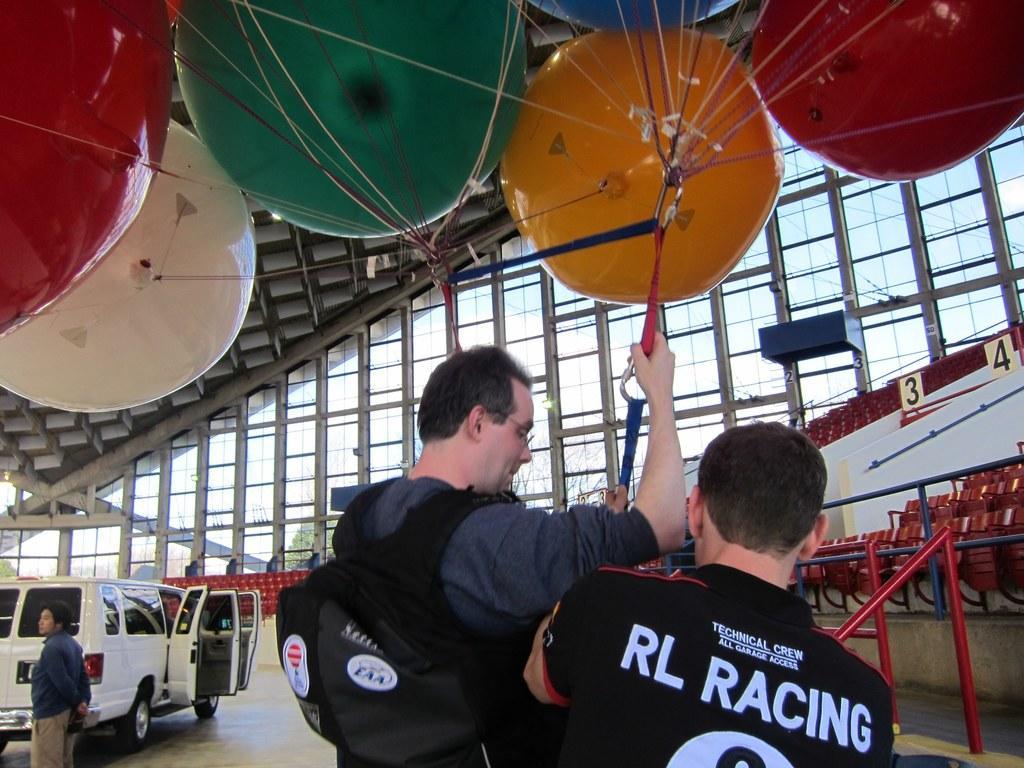In one or two sentences, can you explain what this image depicts? In the foreground of the picture there are two men. At the top there are balloons. On the left there is a van and a person standing. On the right there are chairs and railing. In the background there are glass windows and chairs, outside the window there are trees. Sky is sunny. 